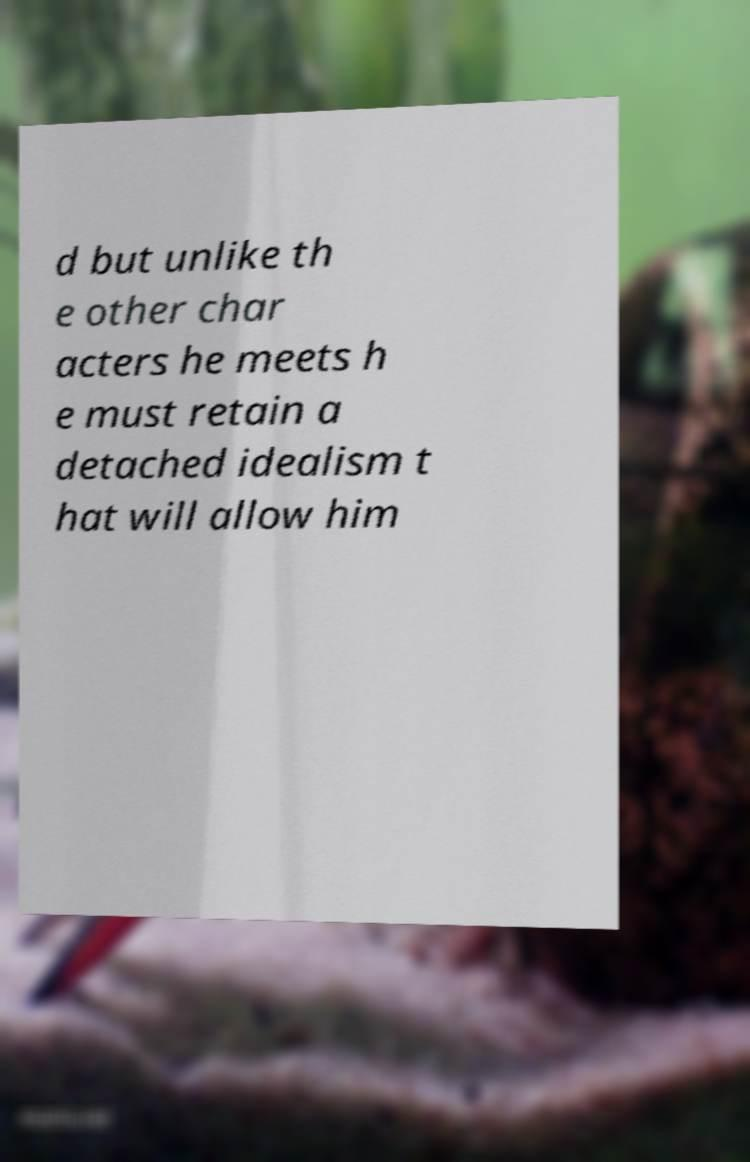Can you read and provide the text displayed in the image?This photo seems to have some interesting text. Can you extract and type it out for me? d but unlike th e other char acters he meets h e must retain a detached idealism t hat will allow him 